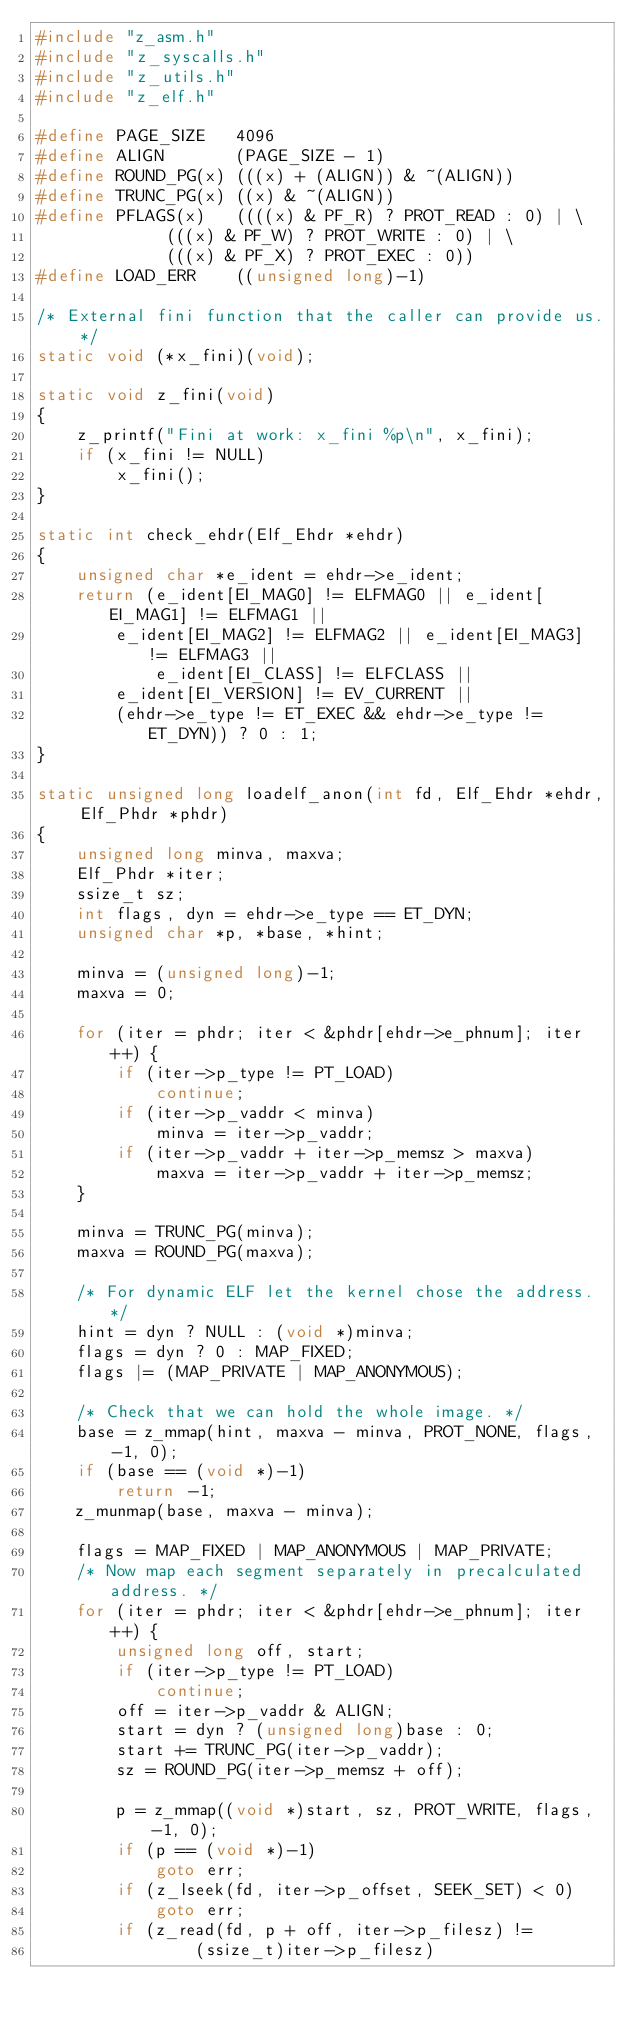<code> <loc_0><loc_0><loc_500><loc_500><_C_>#include "z_asm.h"
#include "z_syscalls.h"
#include "z_utils.h"
#include "z_elf.h"

#define PAGE_SIZE	4096
#define ALIGN		(PAGE_SIZE - 1)
#define ROUND_PG(x)	(((x) + (ALIGN)) & ~(ALIGN))
#define TRUNC_PG(x)	((x) & ~(ALIGN))
#define PFLAGS(x)	((((x) & PF_R) ? PROT_READ : 0) | \
			 (((x) & PF_W) ? PROT_WRITE : 0) | \
			 (((x) & PF_X) ? PROT_EXEC : 0))
#define LOAD_ERR	((unsigned long)-1)

/* External fini function that the caller can provide us. */
static void (*x_fini)(void);

static void z_fini(void)
{
	z_printf("Fini at work: x_fini %p\n", x_fini);
	if (x_fini != NULL)
		x_fini();
}

static int check_ehdr(Elf_Ehdr *ehdr)
{
	unsigned char *e_ident = ehdr->e_ident;
	return (e_ident[EI_MAG0] != ELFMAG0 || e_ident[EI_MAG1] != ELFMAG1 ||
		e_ident[EI_MAG2] != ELFMAG2 || e_ident[EI_MAG3] != ELFMAG3 ||
	    	e_ident[EI_CLASS] != ELFCLASS ||
		e_ident[EI_VERSION] != EV_CURRENT ||
		(ehdr->e_type != ET_EXEC && ehdr->e_type != ET_DYN)) ? 0 : 1;
}

static unsigned long loadelf_anon(int fd, Elf_Ehdr *ehdr, Elf_Phdr *phdr)
{
	unsigned long minva, maxva;
	Elf_Phdr *iter;
	ssize_t sz;
	int flags, dyn = ehdr->e_type == ET_DYN;
	unsigned char *p, *base, *hint;

	minva = (unsigned long)-1;
	maxva = 0;
	
	for (iter = phdr; iter < &phdr[ehdr->e_phnum]; iter++) {
		if (iter->p_type != PT_LOAD)
			continue;
		if (iter->p_vaddr < minva)
			minva = iter->p_vaddr;
		if (iter->p_vaddr + iter->p_memsz > maxva)
			maxva = iter->p_vaddr + iter->p_memsz;
	}

	minva = TRUNC_PG(minva);
	maxva = ROUND_PG(maxva);

	/* For dynamic ELF let the kernel chose the address. */	
	hint = dyn ? NULL : (void *)minva;
	flags = dyn ? 0 : MAP_FIXED;
	flags |= (MAP_PRIVATE | MAP_ANONYMOUS);

	/* Check that we can hold the whole image. */
	base = z_mmap(hint, maxva - minva, PROT_NONE, flags, -1, 0);
	if (base == (void *)-1)
		return -1;
	z_munmap(base, maxva - minva);

	flags = MAP_FIXED | MAP_ANONYMOUS | MAP_PRIVATE;
	/* Now map each segment separately in precalculated address. */
	for (iter = phdr; iter < &phdr[ehdr->e_phnum]; iter++) {
		unsigned long off, start;
		if (iter->p_type != PT_LOAD)
			continue;
		off = iter->p_vaddr & ALIGN;
		start = dyn ? (unsigned long)base : 0;
		start += TRUNC_PG(iter->p_vaddr);
		sz = ROUND_PG(iter->p_memsz + off);

		p = z_mmap((void *)start, sz, PROT_WRITE, flags, -1, 0);
		if (p == (void *)-1)
			goto err;
		if (z_lseek(fd, iter->p_offset, SEEK_SET) < 0)
			goto err;
		if (z_read(fd, p + off, iter->p_filesz) !=
				(ssize_t)iter->p_filesz)</code> 